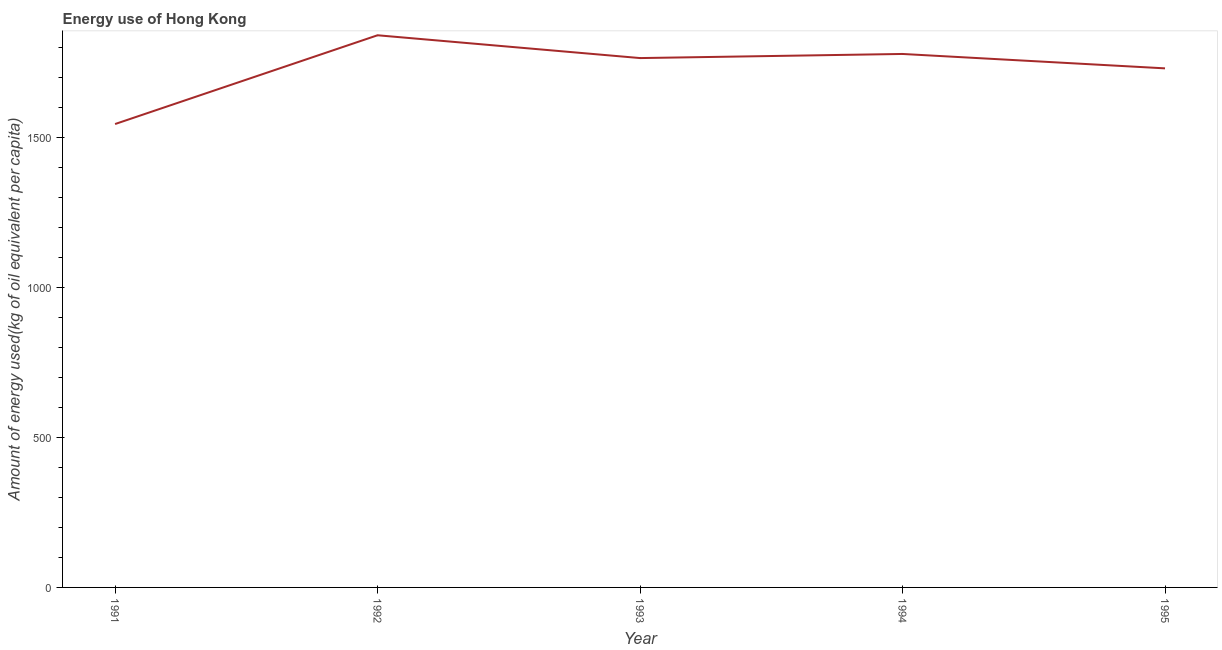What is the amount of energy used in 1995?
Provide a short and direct response. 1729.63. Across all years, what is the maximum amount of energy used?
Provide a succinct answer. 1839.91. Across all years, what is the minimum amount of energy used?
Your response must be concise. 1544.08. In which year was the amount of energy used minimum?
Provide a succinct answer. 1991. What is the sum of the amount of energy used?
Your answer should be compact. 8655.13. What is the difference between the amount of energy used in 1991 and 1995?
Your response must be concise. -185.55. What is the average amount of energy used per year?
Ensure brevity in your answer.  1731.03. What is the median amount of energy used?
Your answer should be compact. 1763.9. In how many years, is the amount of energy used greater than 1100 kg?
Ensure brevity in your answer.  5. What is the ratio of the amount of energy used in 1991 to that in 1993?
Make the answer very short. 0.88. Is the difference between the amount of energy used in 1992 and 1994 greater than the difference between any two years?
Provide a succinct answer. No. What is the difference between the highest and the second highest amount of energy used?
Make the answer very short. 62.3. What is the difference between the highest and the lowest amount of energy used?
Offer a very short reply. 295.83. Does the amount of energy used monotonically increase over the years?
Offer a terse response. No. How many lines are there?
Provide a succinct answer. 1. Are the values on the major ticks of Y-axis written in scientific E-notation?
Your response must be concise. No. Does the graph contain any zero values?
Keep it short and to the point. No. What is the title of the graph?
Your answer should be very brief. Energy use of Hong Kong. What is the label or title of the Y-axis?
Keep it short and to the point. Amount of energy used(kg of oil equivalent per capita). What is the Amount of energy used(kg of oil equivalent per capita) of 1991?
Your answer should be very brief. 1544.08. What is the Amount of energy used(kg of oil equivalent per capita) of 1992?
Offer a very short reply. 1839.91. What is the Amount of energy used(kg of oil equivalent per capita) of 1993?
Ensure brevity in your answer.  1763.9. What is the Amount of energy used(kg of oil equivalent per capita) of 1994?
Your response must be concise. 1777.61. What is the Amount of energy used(kg of oil equivalent per capita) in 1995?
Your answer should be very brief. 1729.63. What is the difference between the Amount of energy used(kg of oil equivalent per capita) in 1991 and 1992?
Ensure brevity in your answer.  -295.83. What is the difference between the Amount of energy used(kg of oil equivalent per capita) in 1991 and 1993?
Provide a succinct answer. -219.83. What is the difference between the Amount of energy used(kg of oil equivalent per capita) in 1991 and 1994?
Give a very brief answer. -233.53. What is the difference between the Amount of energy used(kg of oil equivalent per capita) in 1991 and 1995?
Your answer should be compact. -185.55. What is the difference between the Amount of energy used(kg of oil equivalent per capita) in 1992 and 1993?
Your response must be concise. 76.01. What is the difference between the Amount of energy used(kg of oil equivalent per capita) in 1992 and 1994?
Give a very brief answer. 62.3. What is the difference between the Amount of energy used(kg of oil equivalent per capita) in 1992 and 1995?
Make the answer very short. 110.28. What is the difference between the Amount of energy used(kg of oil equivalent per capita) in 1993 and 1994?
Your response must be concise. -13.71. What is the difference between the Amount of energy used(kg of oil equivalent per capita) in 1993 and 1995?
Offer a terse response. 34.27. What is the difference between the Amount of energy used(kg of oil equivalent per capita) in 1994 and 1995?
Give a very brief answer. 47.98. What is the ratio of the Amount of energy used(kg of oil equivalent per capita) in 1991 to that in 1992?
Offer a terse response. 0.84. What is the ratio of the Amount of energy used(kg of oil equivalent per capita) in 1991 to that in 1993?
Your answer should be compact. 0.88. What is the ratio of the Amount of energy used(kg of oil equivalent per capita) in 1991 to that in 1994?
Your response must be concise. 0.87. What is the ratio of the Amount of energy used(kg of oil equivalent per capita) in 1991 to that in 1995?
Keep it short and to the point. 0.89. What is the ratio of the Amount of energy used(kg of oil equivalent per capita) in 1992 to that in 1993?
Your answer should be compact. 1.04. What is the ratio of the Amount of energy used(kg of oil equivalent per capita) in 1992 to that in 1994?
Make the answer very short. 1.03. What is the ratio of the Amount of energy used(kg of oil equivalent per capita) in 1992 to that in 1995?
Offer a terse response. 1.06. What is the ratio of the Amount of energy used(kg of oil equivalent per capita) in 1993 to that in 1995?
Give a very brief answer. 1.02. What is the ratio of the Amount of energy used(kg of oil equivalent per capita) in 1994 to that in 1995?
Offer a terse response. 1.03. 